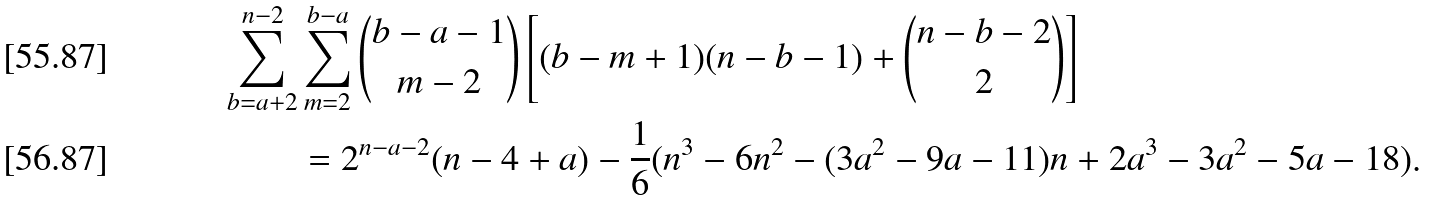Convert formula to latex. <formula><loc_0><loc_0><loc_500><loc_500>\sum _ { b = a + 2 } ^ { n - 2 } & \sum _ { m = 2 } ^ { b - a } \binom { b - a - 1 } { m - 2 } \left [ ( b - m + 1 ) ( n - b - 1 ) + \binom { n - b - 2 } { 2 } \right ] \\ & = 2 ^ { n - a - 2 } ( n - 4 + a ) - \frac { 1 } { 6 } ( n ^ { 3 } - 6 n ^ { 2 } - ( 3 a ^ { 2 } - 9 a - 1 1 ) n + 2 a ^ { 3 } - 3 a ^ { 2 } - 5 a - 1 8 ) .</formula> 